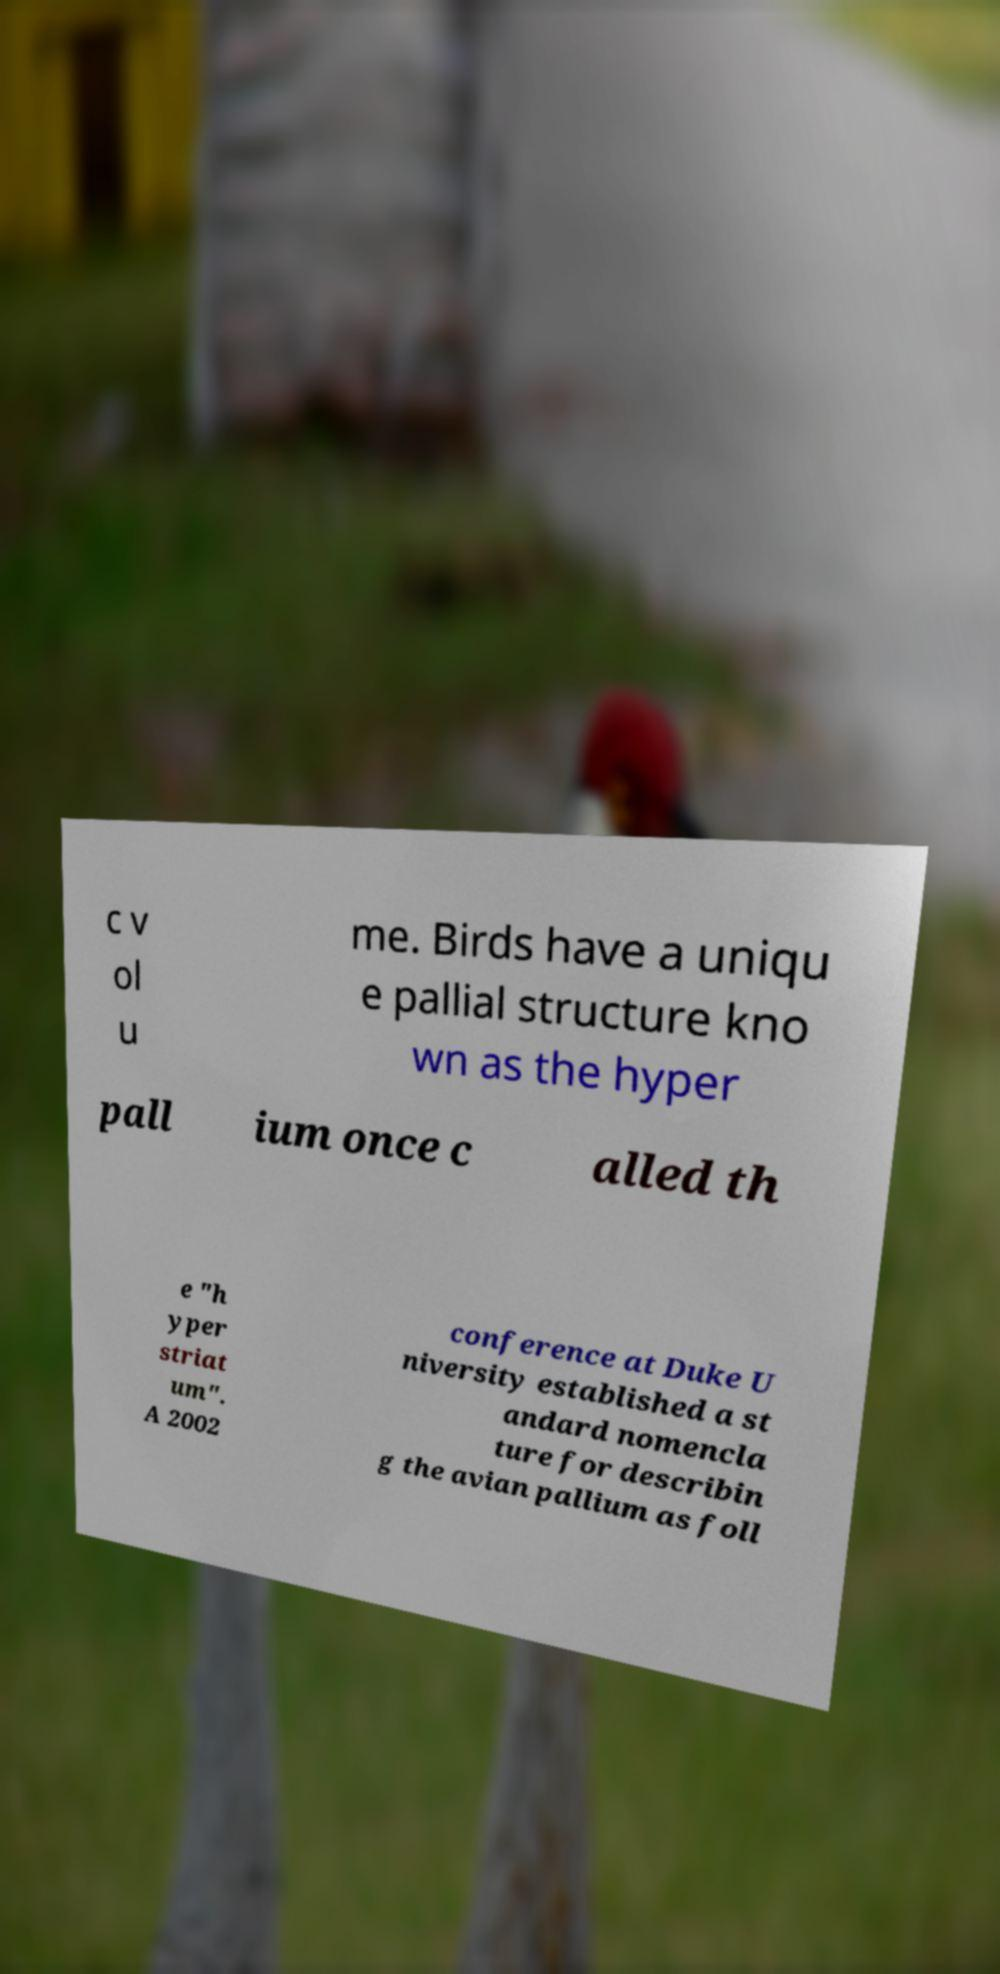Could you assist in decoding the text presented in this image and type it out clearly? c v ol u me. Birds have a uniqu e pallial structure kno wn as the hyper pall ium once c alled th e "h yper striat um". A 2002 conference at Duke U niversity established a st andard nomencla ture for describin g the avian pallium as foll 